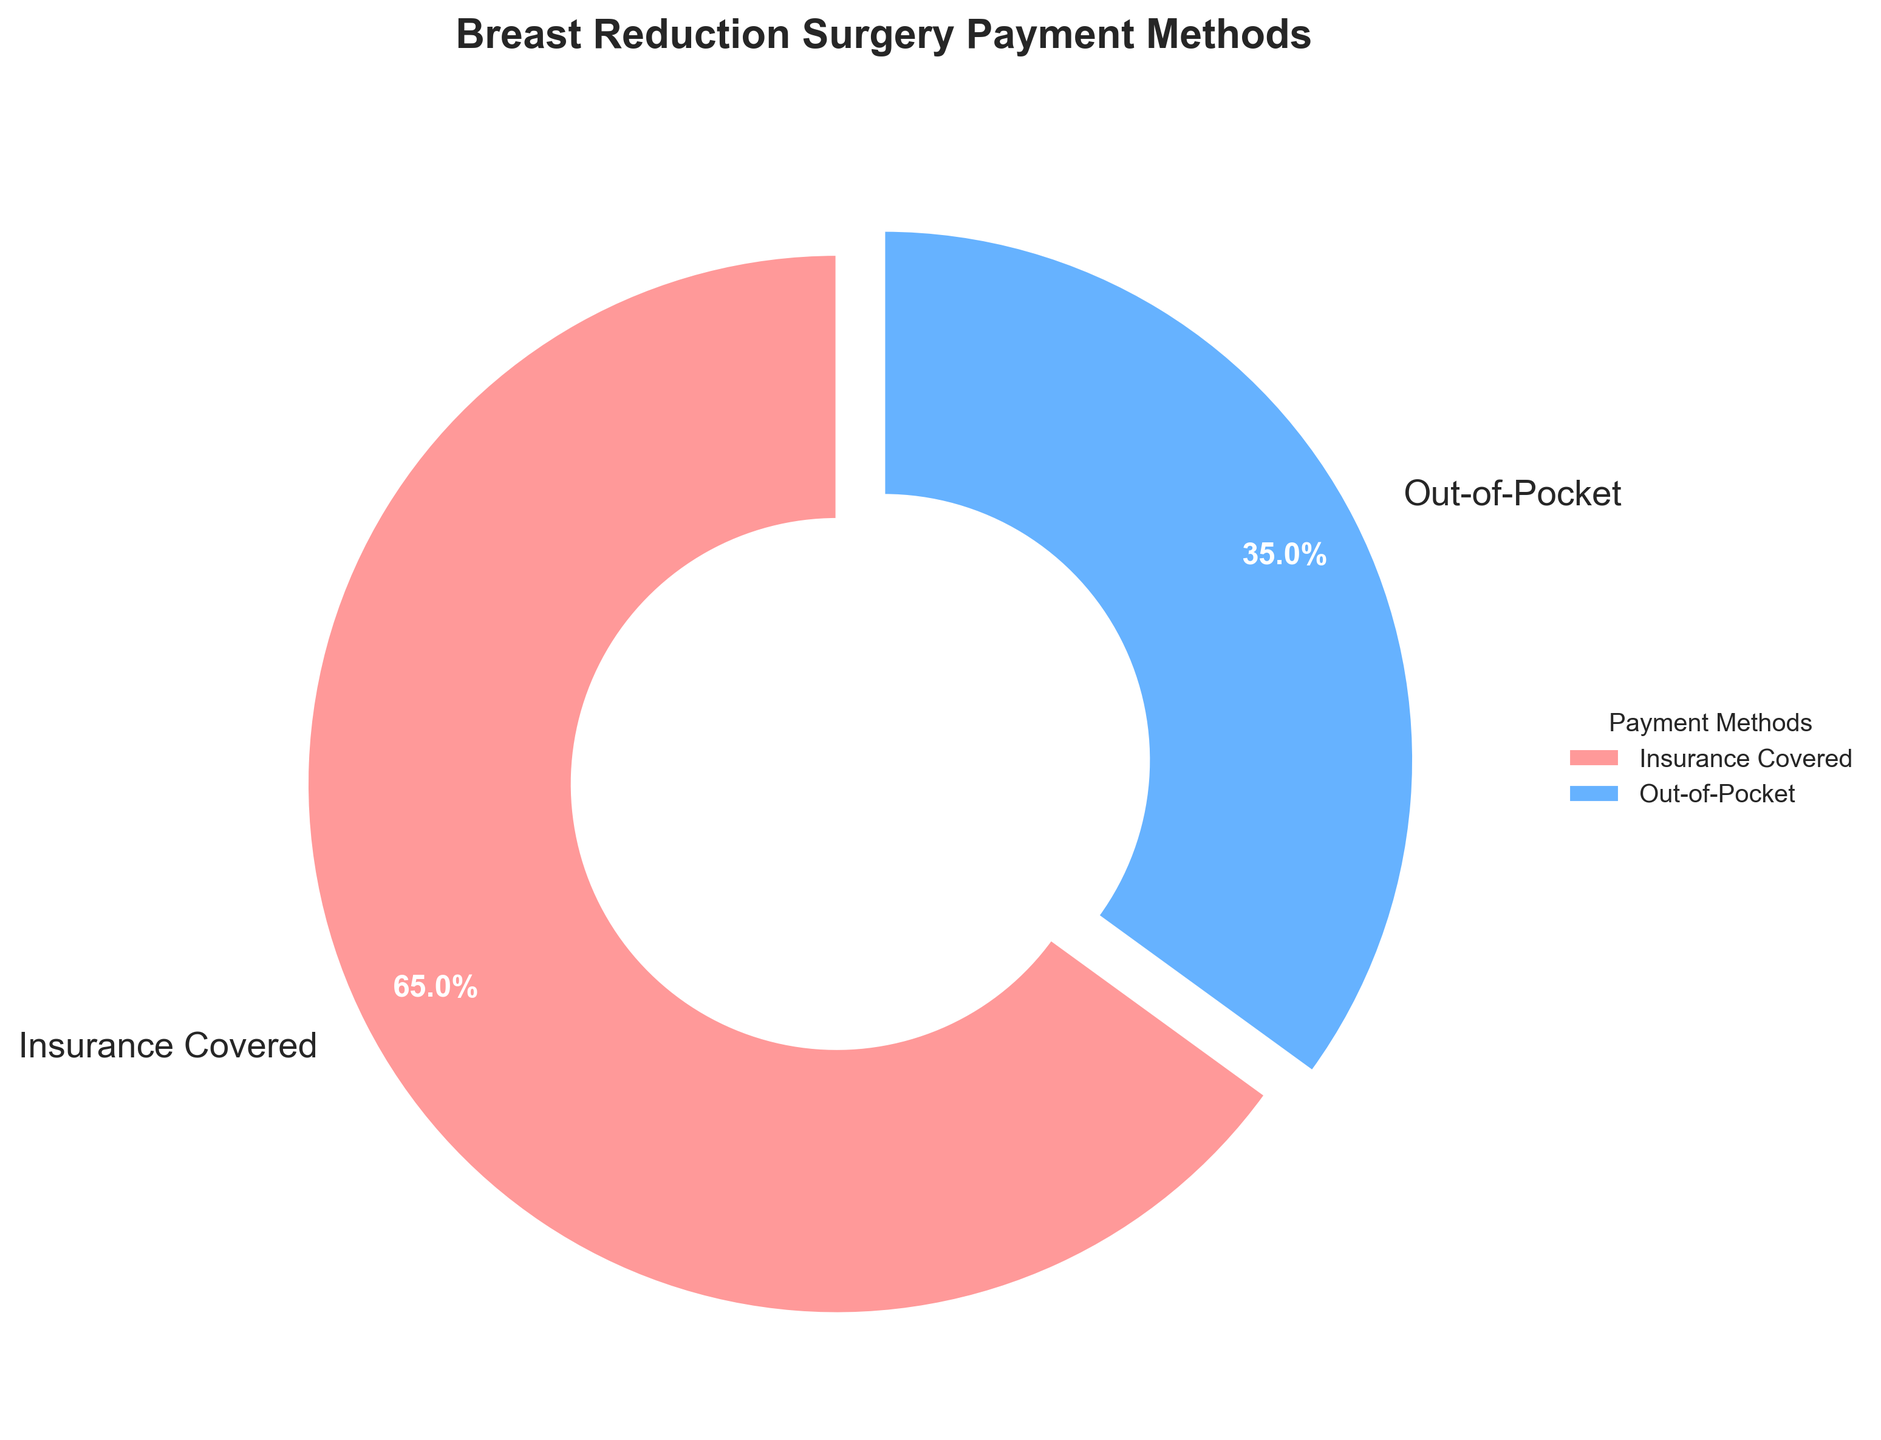Which payment method covers the majority of breast reduction surgeries? By looking at the pie chart, we can see that the slice labeled "Insurance Covered" is larger than the slice labeled "Out-of-Pocket".
Answer: Insurance Covered What percentage of breast reduction surgeries are not covered by insurance? According to the pie chart, 65% of the surgeries are covered by insurance. Hence, the remaining percentage, which is not covered by insurance, is 100% - 65%.
Answer: 35% Which color represents the insurance-covered payment method? The pie chart uses pink for the "Insurance Covered" section and blue for the "Out-of-Pocket" section.
Answer: Pink How much larger is the percentage of insurance-covered surgeries compared to out-of-pocket surgeries? From the pie chart, insurance covers 65% and out-of-pocket covers 35%. The difference between these percentages is 65% - 35%.
Answer: 30% What percentage of breast reduction surgeries require out-of-pocket payments? The slice labeled "Out-of-Pocket" shows the percentage of breast reduction surgeries paid out-of-pocket.
Answer: 35% What fraction of the total are the surgeries covered by insurance? Insurance covers 65% of the surgeries, which corresponds to 0.65 of the total. In fraction terms, this can be expressed as 65/100, which simplifies to 13/20.
Answer: 13/20 How much smaller is the out-of-pocket payment method compared to insurance-covered? The out-of-pocket payment method is 35%. The difference in percentages between the two methods is 65% (insurance-covered) - 35% (out-of-pocket), which equals 30%.
Answer: 30% What are the two segments of the pie chart, and which is larger? The two segments of the pie chart are "Insurance Covered" and "Out-of-Pocket". The "Insurance Covered" segment is larger.
Answer: Insurance Covered What is the percentage representation of insurance coverage, and how does it compare to the out-of-pocket percentage? The insurance coverage is 65%, and comparison-wise, it is almost double the out-of-pocket percentage, which is 35%.
Answer: 65%; nearly double 